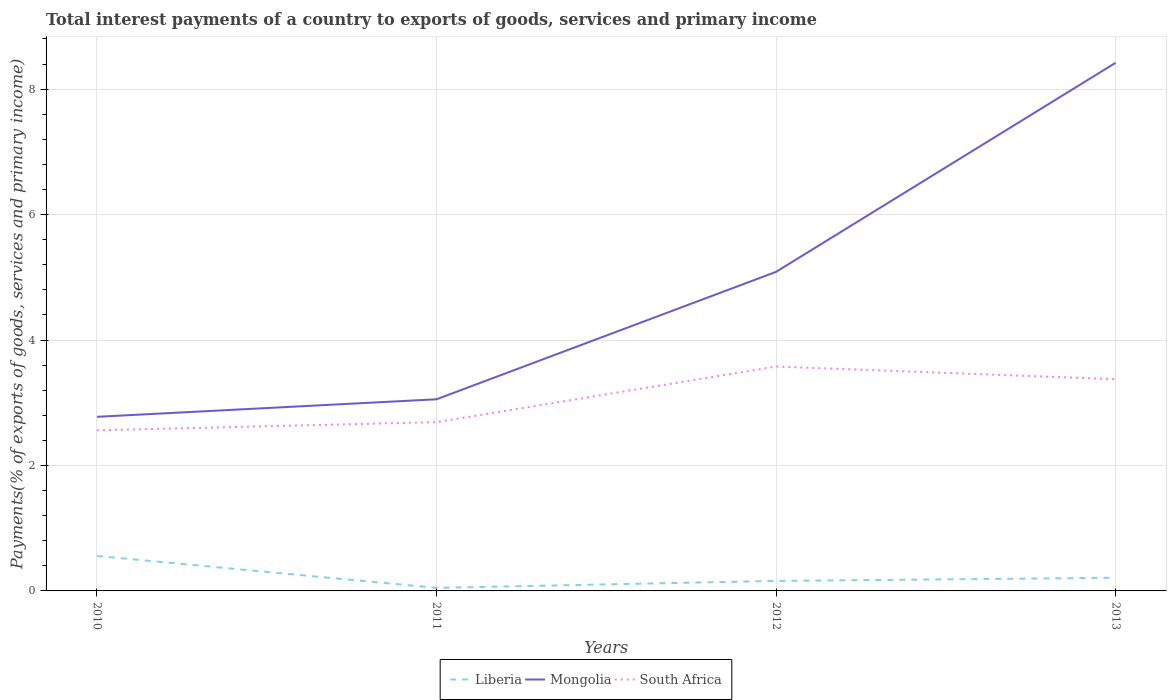Does the line corresponding to Mongolia intersect with the line corresponding to South Africa?
Offer a terse response. No. Is the number of lines equal to the number of legend labels?
Offer a terse response. Yes. Across all years, what is the maximum total interest payments in South Africa?
Your answer should be compact. 2.56. What is the total total interest payments in Liberia in the graph?
Offer a very short reply. 0.51. What is the difference between the highest and the second highest total interest payments in South Africa?
Provide a succinct answer. 1.02. What is the difference between the highest and the lowest total interest payments in Liberia?
Give a very brief answer. 1. What is the difference between two consecutive major ticks on the Y-axis?
Ensure brevity in your answer.  2. Does the graph contain any zero values?
Your answer should be very brief. No. Where does the legend appear in the graph?
Your answer should be compact. Bottom center. How many legend labels are there?
Offer a terse response. 3. What is the title of the graph?
Your response must be concise. Total interest payments of a country to exports of goods, services and primary income. Does "Jamaica" appear as one of the legend labels in the graph?
Make the answer very short. No. What is the label or title of the X-axis?
Provide a short and direct response. Years. What is the label or title of the Y-axis?
Offer a very short reply. Payments(% of exports of goods, services and primary income). What is the Payments(% of exports of goods, services and primary income) of Liberia in 2010?
Ensure brevity in your answer.  0.56. What is the Payments(% of exports of goods, services and primary income) in Mongolia in 2010?
Offer a terse response. 2.78. What is the Payments(% of exports of goods, services and primary income) in South Africa in 2010?
Provide a succinct answer. 2.56. What is the Payments(% of exports of goods, services and primary income) of Liberia in 2011?
Your response must be concise. 0.05. What is the Payments(% of exports of goods, services and primary income) in Mongolia in 2011?
Provide a short and direct response. 3.06. What is the Payments(% of exports of goods, services and primary income) in South Africa in 2011?
Your answer should be compact. 2.69. What is the Payments(% of exports of goods, services and primary income) of Liberia in 2012?
Make the answer very short. 0.16. What is the Payments(% of exports of goods, services and primary income) of Mongolia in 2012?
Ensure brevity in your answer.  5.09. What is the Payments(% of exports of goods, services and primary income) of South Africa in 2012?
Your answer should be very brief. 3.58. What is the Payments(% of exports of goods, services and primary income) of Liberia in 2013?
Give a very brief answer. 0.21. What is the Payments(% of exports of goods, services and primary income) in Mongolia in 2013?
Your answer should be very brief. 8.42. What is the Payments(% of exports of goods, services and primary income) in South Africa in 2013?
Make the answer very short. 3.37. Across all years, what is the maximum Payments(% of exports of goods, services and primary income) in Liberia?
Your response must be concise. 0.56. Across all years, what is the maximum Payments(% of exports of goods, services and primary income) in Mongolia?
Ensure brevity in your answer.  8.42. Across all years, what is the maximum Payments(% of exports of goods, services and primary income) of South Africa?
Ensure brevity in your answer.  3.58. Across all years, what is the minimum Payments(% of exports of goods, services and primary income) of Liberia?
Your response must be concise. 0.05. Across all years, what is the minimum Payments(% of exports of goods, services and primary income) of Mongolia?
Offer a terse response. 2.78. Across all years, what is the minimum Payments(% of exports of goods, services and primary income) in South Africa?
Offer a terse response. 2.56. What is the total Payments(% of exports of goods, services and primary income) in Liberia in the graph?
Offer a terse response. 0.98. What is the total Payments(% of exports of goods, services and primary income) of Mongolia in the graph?
Your response must be concise. 19.34. What is the total Payments(% of exports of goods, services and primary income) of South Africa in the graph?
Ensure brevity in your answer.  12.2. What is the difference between the Payments(% of exports of goods, services and primary income) in Liberia in 2010 and that in 2011?
Ensure brevity in your answer.  0.51. What is the difference between the Payments(% of exports of goods, services and primary income) in Mongolia in 2010 and that in 2011?
Your response must be concise. -0.28. What is the difference between the Payments(% of exports of goods, services and primary income) in South Africa in 2010 and that in 2011?
Offer a terse response. -0.13. What is the difference between the Payments(% of exports of goods, services and primary income) of Liberia in 2010 and that in 2012?
Your answer should be very brief. 0.4. What is the difference between the Payments(% of exports of goods, services and primary income) of Mongolia in 2010 and that in 2012?
Your response must be concise. -2.31. What is the difference between the Payments(% of exports of goods, services and primary income) in South Africa in 2010 and that in 2012?
Your response must be concise. -1.02. What is the difference between the Payments(% of exports of goods, services and primary income) of Liberia in 2010 and that in 2013?
Provide a short and direct response. 0.35. What is the difference between the Payments(% of exports of goods, services and primary income) of Mongolia in 2010 and that in 2013?
Your response must be concise. -5.64. What is the difference between the Payments(% of exports of goods, services and primary income) of South Africa in 2010 and that in 2013?
Your answer should be compact. -0.81. What is the difference between the Payments(% of exports of goods, services and primary income) of Liberia in 2011 and that in 2012?
Your answer should be very brief. -0.11. What is the difference between the Payments(% of exports of goods, services and primary income) of Mongolia in 2011 and that in 2012?
Provide a short and direct response. -2.03. What is the difference between the Payments(% of exports of goods, services and primary income) in South Africa in 2011 and that in 2012?
Provide a short and direct response. -0.89. What is the difference between the Payments(% of exports of goods, services and primary income) of Liberia in 2011 and that in 2013?
Keep it short and to the point. -0.16. What is the difference between the Payments(% of exports of goods, services and primary income) in Mongolia in 2011 and that in 2013?
Provide a succinct answer. -5.36. What is the difference between the Payments(% of exports of goods, services and primary income) in South Africa in 2011 and that in 2013?
Provide a short and direct response. -0.68. What is the difference between the Payments(% of exports of goods, services and primary income) of Liberia in 2012 and that in 2013?
Ensure brevity in your answer.  -0.05. What is the difference between the Payments(% of exports of goods, services and primary income) of Mongolia in 2012 and that in 2013?
Your answer should be compact. -3.33. What is the difference between the Payments(% of exports of goods, services and primary income) in South Africa in 2012 and that in 2013?
Ensure brevity in your answer.  0.2. What is the difference between the Payments(% of exports of goods, services and primary income) of Liberia in 2010 and the Payments(% of exports of goods, services and primary income) of Mongolia in 2011?
Ensure brevity in your answer.  -2.5. What is the difference between the Payments(% of exports of goods, services and primary income) of Liberia in 2010 and the Payments(% of exports of goods, services and primary income) of South Africa in 2011?
Keep it short and to the point. -2.13. What is the difference between the Payments(% of exports of goods, services and primary income) in Mongolia in 2010 and the Payments(% of exports of goods, services and primary income) in South Africa in 2011?
Offer a very short reply. 0.09. What is the difference between the Payments(% of exports of goods, services and primary income) in Liberia in 2010 and the Payments(% of exports of goods, services and primary income) in Mongolia in 2012?
Offer a very short reply. -4.53. What is the difference between the Payments(% of exports of goods, services and primary income) of Liberia in 2010 and the Payments(% of exports of goods, services and primary income) of South Africa in 2012?
Offer a terse response. -3.02. What is the difference between the Payments(% of exports of goods, services and primary income) in Mongolia in 2010 and the Payments(% of exports of goods, services and primary income) in South Africa in 2012?
Keep it short and to the point. -0.8. What is the difference between the Payments(% of exports of goods, services and primary income) of Liberia in 2010 and the Payments(% of exports of goods, services and primary income) of Mongolia in 2013?
Offer a terse response. -7.86. What is the difference between the Payments(% of exports of goods, services and primary income) of Liberia in 2010 and the Payments(% of exports of goods, services and primary income) of South Africa in 2013?
Your answer should be compact. -2.82. What is the difference between the Payments(% of exports of goods, services and primary income) of Mongolia in 2010 and the Payments(% of exports of goods, services and primary income) of South Africa in 2013?
Provide a succinct answer. -0.6. What is the difference between the Payments(% of exports of goods, services and primary income) in Liberia in 2011 and the Payments(% of exports of goods, services and primary income) in Mongolia in 2012?
Make the answer very short. -5.04. What is the difference between the Payments(% of exports of goods, services and primary income) of Liberia in 2011 and the Payments(% of exports of goods, services and primary income) of South Africa in 2012?
Give a very brief answer. -3.53. What is the difference between the Payments(% of exports of goods, services and primary income) of Mongolia in 2011 and the Payments(% of exports of goods, services and primary income) of South Africa in 2012?
Offer a very short reply. -0.52. What is the difference between the Payments(% of exports of goods, services and primary income) in Liberia in 2011 and the Payments(% of exports of goods, services and primary income) in Mongolia in 2013?
Your response must be concise. -8.37. What is the difference between the Payments(% of exports of goods, services and primary income) of Liberia in 2011 and the Payments(% of exports of goods, services and primary income) of South Africa in 2013?
Your response must be concise. -3.33. What is the difference between the Payments(% of exports of goods, services and primary income) in Mongolia in 2011 and the Payments(% of exports of goods, services and primary income) in South Africa in 2013?
Ensure brevity in your answer.  -0.32. What is the difference between the Payments(% of exports of goods, services and primary income) of Liberia in 2012 and the Payments(% of exports of goods, services and primary income) of Mongolia in 2013?
Provide a short and direct response. -8.26. What is the difference between the Payments(% of exports of goods, services and primary income) in Liberia in 2012 and the Payments(% of exports of goods, services and primary income) in South Africa in 2013?
Give a very brief answer. -3.22. What is the difference between the Payments(% of exports of goods, services and primary income) of Mongolia in 2012 and the Payments(% of exports of goods, services and primary income) of South Africa in 2013?
Offer a terse response. 1.71. What is the average Payments(% of exports of goods, services and primary income) of Liberia per year?
Give a very brief answer. 0.24. What is the average Payments(% of exports of goods, services and primary income) of Mongolia per year?
Keep it short and to the point. 4.83. What is the average Payments(% of exports of goods, services and primary income) in South Africa per year?
Provide a short and direct response. 3.05. In the year 2010, what is the difference between the Payments(% of exports of goods, services and primary income) of Liberia and Payments(% of exports of goods, services and primary income) of Mongolia?
Offer a terse response. -2.22. In the year 2010, what is the difference between the Payments(% of exports of goods, services and primary income) in Liberia and Payments(% of exports of goods, services and primary income) in South Africa?
Your response must be concise. -2. In the year 2010, what is the difference between the Payments(% of exports of goods, services and primary income) of Mongolia and Payments(% of exports of goods, services and primary income) of South Africa?
Offer a very short reply. 0.22. In the year 2011, what is the difference between the Payments(% of exports of goods, services and primary income) of Liberia and Payments(% of exports of goods, services and primary income) of Mongolia?
Offer a terse response. -3.01. In the year 2011, what is the difference between the Payments(% of exports of goods, services and primary income) of Liberia and Payments(% of exports of goods, services and primary income) of South Africa?
Provide a succinct answer. -2.64. In the year 2011, what is the difference between the Payments(% of exports of goods, services and primary income) of Mongolia and Payments(% of exports of goods, services and primary income) of South Africa?
Make the answer very short. 0.36. In the year 2012, what is the difference between the Payments(% of exports of goods, services and primary income) of Liberia and Payments(% of exports of goods, services and primary income) of Mongolia?
Provide a short and direct response. -4.93. In the year 2012, what is the difference between the Payments(% of exports of goods, services and primary income) in Liberia and Payments(% of exports of goods, services and primary income) in South Africa?
Your response must be concise. -3.42. In the year 2012, what is the difference between the Payments(% of exports of goods, services and primary income) of Mongolia and Payments(% of exports of goods, services and primary income) of South Africa?
Your answer should be very brief. 1.51. In the year 2013, what is the difference between the Payments(% of exports of goods, services and primary income) of Liberia and Payments(% of exports of goods, services and primary income) of Mongolia?
Your response must be concise. -8.21. In the year 2013, what is the difference between the Payments(% of exports of goods, services and primary income) in Liberia and Payments(% of exports of goods, services and primary income) in South Africa?
Make the answer very short. -3.17. In the year 2013, what is the difference between the Payments(% of exports of goods, services and primary income) in Mongolia and Payments(% of exports of goods, services and primary income) in South Africa?
Give a very brief answer. 5.04. What is the ratio of the Payments(% of exports of goods, services and primary income) in Liberia in 2010 to that in 2011?
Give a very brief answer. 11.49. What is the ratio of the Payments(% of exports of goods, services and primary income) in Mongolia in 2010 to that in 2011?
Your answer should be compact. 0.91. What is the ratio of the Payments(% of exports of goods, services and primary income) of South Africa in 2010 to that in 2011?
Make the answer very short. 0.95. What is the ratio of the Payments(% of exports of goods, services and primary income) of Liberia in 2010 to that in 2012?
Offer a terse response. 3.5. What is the ratio of the Payments(% of exports of goods, services and primary income) in Mongolia in 2010 to that in 2012?
Your response must be concise. 0.55. What is the ratio of the Payments(% of exports of goods, services and primary income) of South Africa in 2010 to that in 2012?
Your answer should be compact. 0.72. What is the ratio of the Payments(% of exports of goods, services and primary income) in Liberia in 2010 to that in 2013?
Give a very brief answer. 2.66. What is the ratio of the Payments(% of exports of goods, services and primary income) in Mongolia in 2010 to that in 2013?
Your answer should be very brief. 0.33. What is the ratio of the Payments(% of exports of goods, services and primary income) of South Africa in 2010 to that in 2013?
Your answer should be very brief. 0.76. What is the ratio of the Payments(% of exports of goods, services and primary income) in Liberia in 2011 to that in 2012?
Your answer should be compact. 0.3. What is the ratio of the Payments(% of exports of goods, services and primary income) of Mongolia in 2011 to that in 2012?
Your answer should be very brief. 0.6. What is the ratio of the Payments(% of exports of goods, services and primary income) of South Africa in 2011 to that in 2012?
Offer a very short reply. 0.75. What is the ratio of the Payments(% of exports of goods, services and primary income) in Liberia in 2011 to that in 2013?
Keep it short and to the point. 0.23. What is the ratio of the Payments(% of exports of goods, services and primary income) of Mongolia in 2011 to that in 2013?
Offer a very short reply. 0.36. What is the ratio of the Payments(% of exports of goods, services and primary income) in South Africa in 2011 to that in 2013?
Keep it short and to the point. 0.8. What is the ratio of the Payments(% of exports of goods, services and primary income) in Liberia in 2012 to that in 2013?
Offer a terse response. 0.76. What is the ratio of the Payments(% of exports of goods, services and primary income) in Mongolia in 2012 to that in 2013?
Keep it short and to the point. 0.6. What is the ratio of the Payments(% of exports of goods, services and primary income) of South Africa in 2012 to that in 2013?
Your answer should be compact. 1.06. What is the difference between the highest and the second highest Payments(% of exports of goods, services and primary income) in Liberia?
Keep it short and to the point. 0.35. What is the difference between the highest and the second highest Payments(% of exports of goods, services and primary income) in Mongolia?
Ensure brevity in your answer.  3.33. What is the difference between the highest and the second highest Payments(% of exports of goods, services and primary income) in South Africa?
Provide a short and direct response. 0.2. What is the difference between the highest and the lowest Payments(% of exports of goods, services and primary income) in Liberia?
Offer a terse response. 0.51. What is the difference between the highest and the lowest Payments(% of exports of goods, services and primary income) of Mongolia?
Your answer should be compact. 5.64. What is the difference between the highest and the lowest Payments(% of exports of goods, services and primary income) of South Africa?
Make the answer very short. 1.02. 